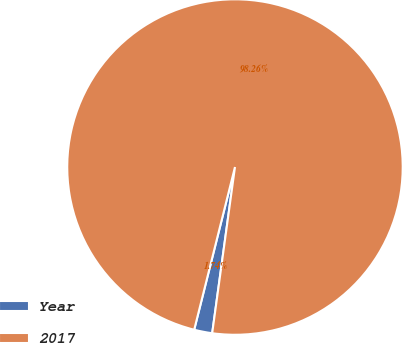Convert chart. <chart><loc_0><loc_0><loc_500><loc_500><pie_chart><fcel>Year<fcel>2017<nl><fcel>1.74%<fcel>98.26%<nl></chart> 